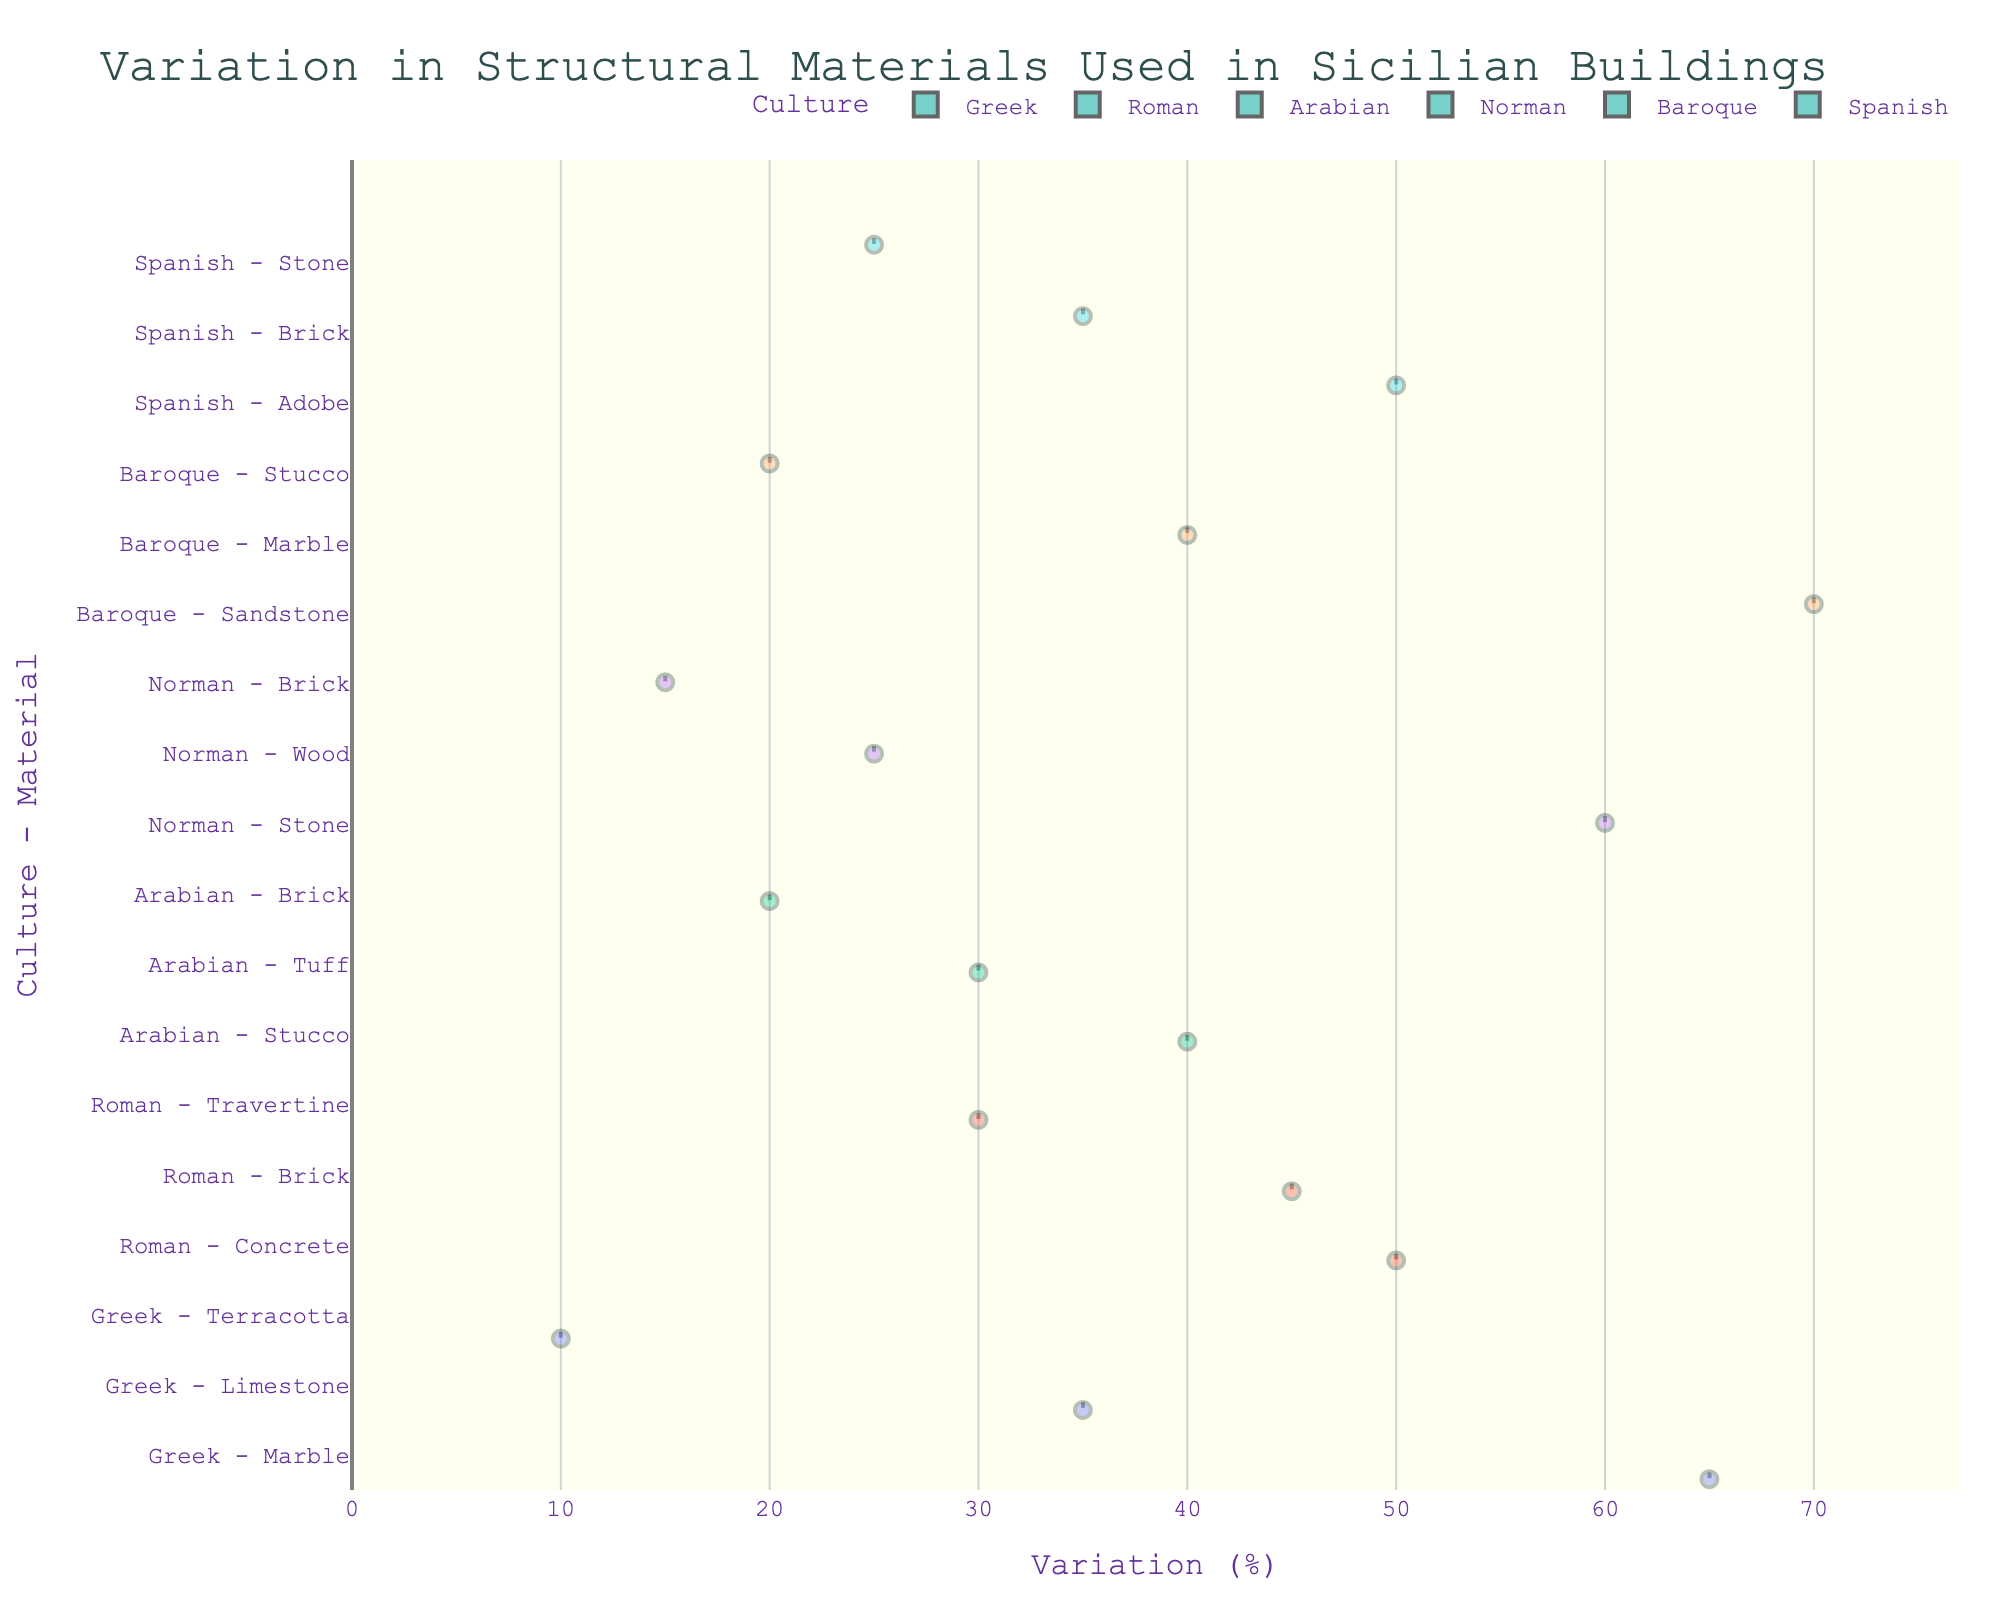Which culture-material combination shows the highest variation? The plot indicates that "Baroque - Sandstone" has the highest variation percentage, represented by the violin's width expanding the most at the maximum point.
Answer: Baroque - Sandstone What is the median variation for the Greek culture? The boxplot inside the violin chart for Greek culture indicates that the median line varies around the middle for each material. Specifically, for Marble, the median visually appears to be higher than for Limestone and Terracotta.
Answer: Marble: 65, Limestone: 35, Terracotta: 10 Which culture uses brick in Sicilian buildings, and how does the variation differ among these cultures? The plot shows that Roman, Arabian, Norman, and Spanish cultures use brick. By examining the width and position of violins and the mean line, we can infer that Roman has the highest variation (45%), followed by Arabian (20%), Norman (15%), and Spanish (35%).
Answer: Roman: 45%, Arabian: 20%, Norman: 15%, Spanish: 35% Between Norman stone and Norman wood, which has a higher variation, and by how much? By comparing the violins for Norman’s materials, the visualization shows that stone has a higher variation (60%) than wood (25%). The numerical difference can be calculated as 60 - 25.
Answer: Stone: 35% What is the range of variation for materials used by the Baroque culture? The boxplots and the spread of the violins for Baroque culture indicate the range from 20% to 70%.
Answer: 20% to 70% How does the variation of materials used by the Greek culture compare to those used by the Roman culture? The plot shows that the Greek culture has materials with variations spread between 10% and 65%, while Roman materials have a variation from 30% to 50%. The range for Roman materials appears narrower compared to Greek.
Answer: Greek: 10% - 65%, Roman: 30% - 50% Which culture-material combination has the closest variation to 50%? By closely observing the violin plots, Roman concrete stands out as having a variation roughly at 50%.
Answer: Roman - Concrete How many materials are used exclusively by the Baroque culture in Sicilian buildings? Observing the unique material labels associated with each culture in the horizontal violin chart reveals that Baroque uniquely includes Sandstone and Marble.
Answer: Sandstone, Marble (total: 2 materials) What cultural influence shows the least variation in materials, and what is that variation? Referring to the plot details, Greek Terracotta has the least variation depicted at the very narrowest point of the violin at 10%.
Answer: Greek - Terracotta 